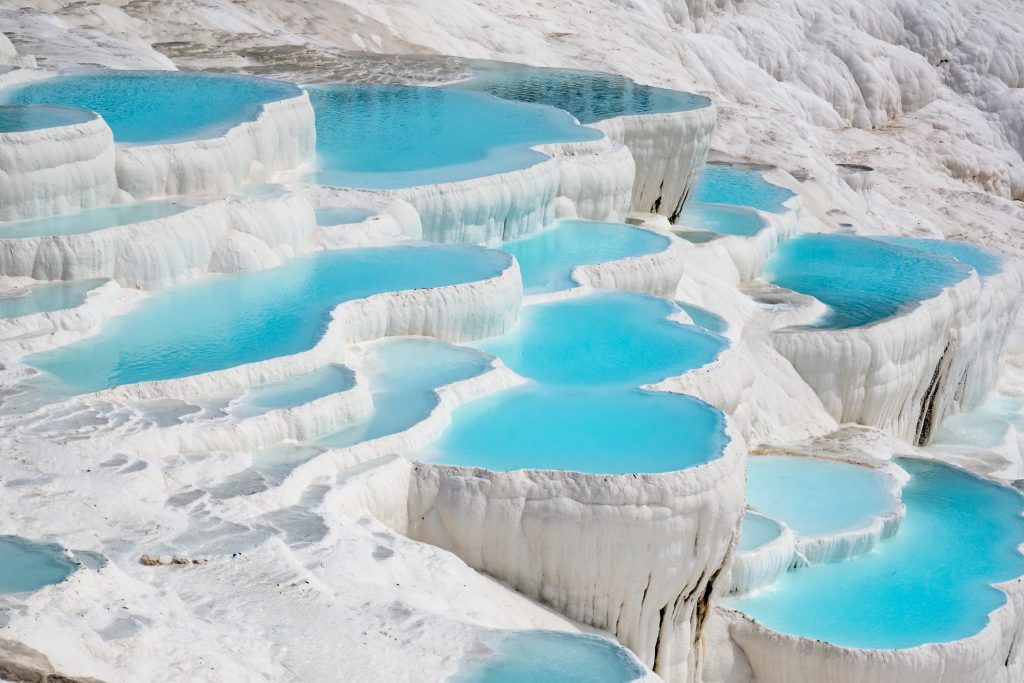If an artist visited Pamukkale, what kind of artwork might they create? An artist visiting Pamukkale might be inspired to create a multitude of artworks. They might paint an expansive landscape capturing the terraces' unique formations and the vibrant blues and whites of the water and travertine. Alternatively, a more abstract approach could focus on the intricate details and textures of the terraces, emphasizing the play of light and shadow. Sculpture artists could fashion pieces mimicking the layers and contours of the travertine terraces, capturing the fluidity of the formations frozen in stone. A digital artist might create a surreal rendition, incorporating mythical creatures or fantastical elements inspired by the natural beauty of Pamukkale. 